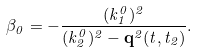<formula> <loc_0><loc_0><loc_500><loc_500>\beta _ { 0 } = - \frac { ( k _ { 1 } ^ { 0 } ) ^ { 2 } } { ( k _ { 2 } ^ { 0 } ) ^ { 2 } - { \mathbf q } ^ { 2 } ( t , t _ { 2 } ) } .</formula> 